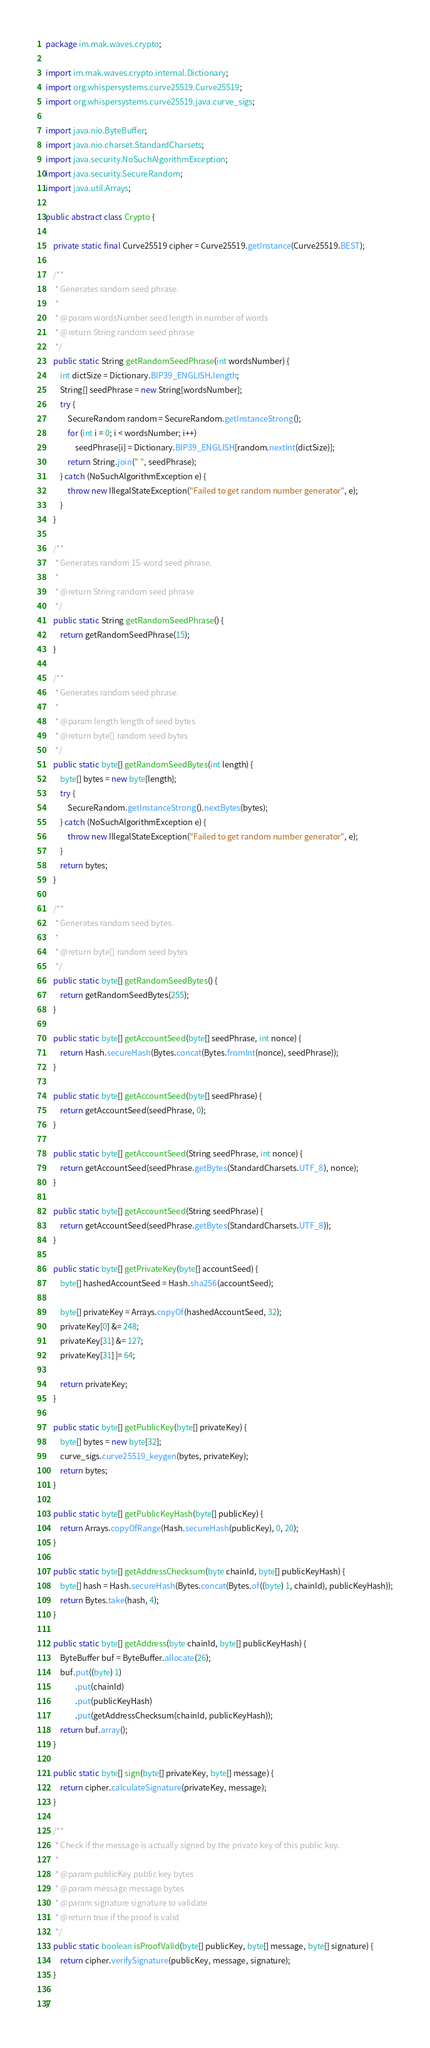<code> <loc_0><loc_0><loc_500><loc_500><_Java_>package im.mak.waves.crypto;

import im.mak.waves.crypto.internal.Dictionary;
import org.whispersystems.curve25519.Curve25519;
import org.whispersystems.curve25519.java.curve_sigs;

import java.nio.ByteBuffer;
import java.nio.charset.StandardCharsets;
import java.security.NoSuchAlgorithmException;
import java.security.SecureRandom;
import java.util.Arrays;

public abstract class Crypto {

    private static final Curve25519 cipher = Curve25519.getInstance(Curve25519.BEST);

    /**
     * Generates random seed phrase.
     *
     * @param wordsNumber seed length in number of words
     * @return String random seed phrase
     */
    public static String getRandomSeedPhrase(int wordsNumber) {
        int dictSize = Dictionary.BIP39_ENGLISH.length;
        String[] seedPhrase = new String[wordsNumber];
        try {
            SecureRandom random = SecureRandom.getInstanceStrong();
            for (int i = 0; i < wordsNumber; i++)
                seedPhrase[i] = Dictionary.BIP39_ENGLISH[random.nextInt(dictSize)];
            return String.join(" ", seedPhrase);
        } catch (NoSuchAlgorithmException e) {
            throw new IllegalStateException("Failed to get random number generator", e);
        }
    }

    /**
     * Generates random 15-word seed phrase.
     *
     * @return String random seed phrase
     */
    public static String getRandomSeedPhrase() {
        return getRandomSeedPhrase(15);
    }

    /**
     * Generates random seed phrase.
     *
     * @param length length of seed bytes
     * @return byte[] random seed bytes
     */
    public static byte[] getRandomSeedBytes(int length) {
        byte[] bytes = new byte[length];
        try {
            SecureRandom.getInstanceStrong().nextBytes(bytes);
        } catch (NoSuchAlgorithmException e) {
            throw new IllegalStateException("Failed to get random number generator", e);
        }
        return bytes;
    }

    /**
     * Generates random seed bytes.
     *
     * @return byte[] random seed bytes
     */
    public static byte[] getRandomSeedBytes() {
        return getRandomSeedBytes(255);
    }

    public static byte[] getAccountSeed(byte[] seedPhrase, int nonce) {
        return Hash.secureHash(Bytes.concat(Bytes.fromInt(nonce), seedPhrase));
    }

    public static byte[] getAccountSeed(byte[] seedPhrase) {
        return getAccountSeed(seedPhrase, 0);
    }

    public static byte[] getAccountSeed(String seedPhrase, int nonce) {
        return getAccountSeed(seedPhrase.getBytes(StandardCharsets.UTF_8), nonce);
    }

    public static byte[] getAccountSeed(String seedPhrase) {
        return getAccountSeed(seedPhrase.getBytes(StandardCharsets.UTF_8));
    }

    public static byte[] getPrivateKey(byte[] accountSeed) {
        byte[] hashedAccountSeed = Hash.sha256(accountSeed);

        byte[] privateKey = Arrays.copyOf(hashedAccountSeed, 32);
        privateKey[0] &= 248;
        privateKey[31] &= 127;
        privateKey[31] |= 64;

        return privateKey;
    }

    public static byte[] getPublicKey(byte[] privateKey) {
        byte[] bytes = new byte[32];
        curve_sigs.curve25519_keygen(bytes, privateKey);
        return bytes;
    }

    public static byte[] getPublicKeyHash(byte[] publicKey) {
        return Arrays.copyOfRange(Hash.secureHash(publicKey), 0, 20);
    }

    public static byte[] getAddressChecksum(byte chainId, byte[] publicKeyHash) {
        byte[] hash = Hash.secureHash(Bytes.concat(Bytes.of((byte) 1, chainId), publicKeyHash));
        return Bytes.take(hash, 4);
    }

    public static byte[] getAddress(byte chainId, byte[] publicKeyHash) {
        ByteBuffer buf = ByteBuffer.allocate(26);
        buf.put((byte) 1)
                .put(chainId)
                .put(publicKeyHash)
                .put(getAddressChecksum(chainId, publicKeyHash));
        return buf.array();
    }

    public static byte[] sign(byte[] privateKey, byte[] message) {
        return cipher.calculateSignature(privateKey, message);
    }

    /**
     * Check if the message is actually signed by the private key of this public key.
     *
     * @param publicKey public key bytes
     * @param message message bytes
     * @param signature signature to validate
     * @return true if the proof is valid
     */
    public static boolean isProofValid(byte[] publicKey, byte[] message, byte[] signature) {
        return cipher.verifySignature(publicKey, message, signature);
    }

}
</code> 